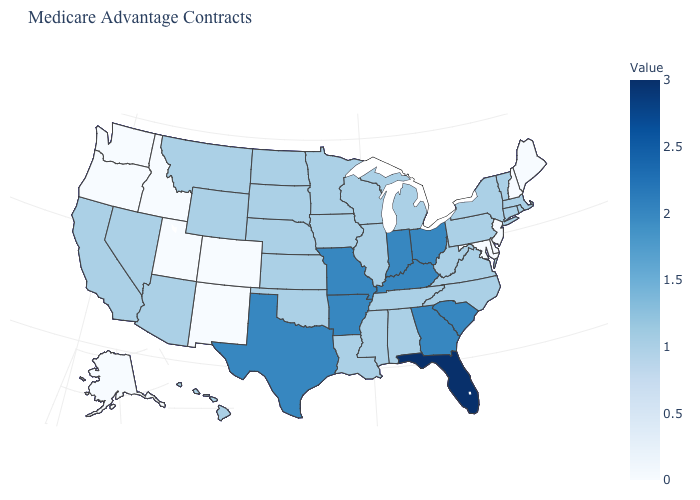Does the map have missing data?
Concise answer only. No. 